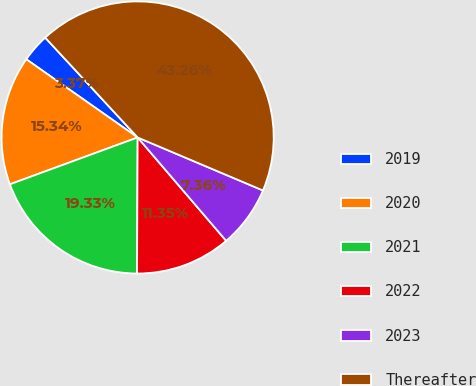<chart> <loc_0><loc_0><loc_500><loc_500><pie_chart><fcel>2019<fcel>2020<fcel>2021<fcel>2022<fcel>2023<fcel>Thereafter<nl><fcel>3.37%<fcel>15.34%<fcel>19.33%<fcel>11.35%<fcel>7.36%<fcel>43.26%<nl></chart> 